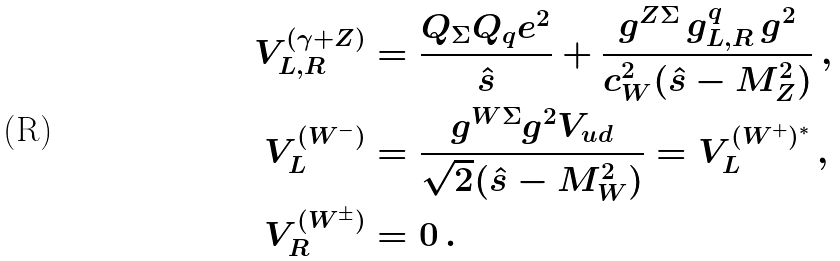<formula> <loc_0><loc_0><loc_500><loc_500>V _ { L , R } ^ { ( \gamma + Z ) } & = \frac { Q _ { \Sigma } Q _ { q } e ^ { 2 } } { \hat { s } } + \frac { g ^ { Z \Sigma } \, g _ { L , R } ^ { q } \, g ^ { 2 } } { c _ { W } ^ { 2 } ( \hat { s } - M _ { Z } ^ { 2 } ) } \, , \\ V _ { L } ^ { ( W ^ { - } ) } & = \frac { g ^ { W \Sigma } g ^ { 2 } V _ { u d } } { \sqrt { 2 } ( \hat { s } - M _ { W } ^ { 2 } ) } = V _ { L } ^ { ( W ^ { + } ) ^ { * } } \, , \\ V _ { R } ^ { ( W ^ { \pm } ) } & = 0 \, .</formula> 